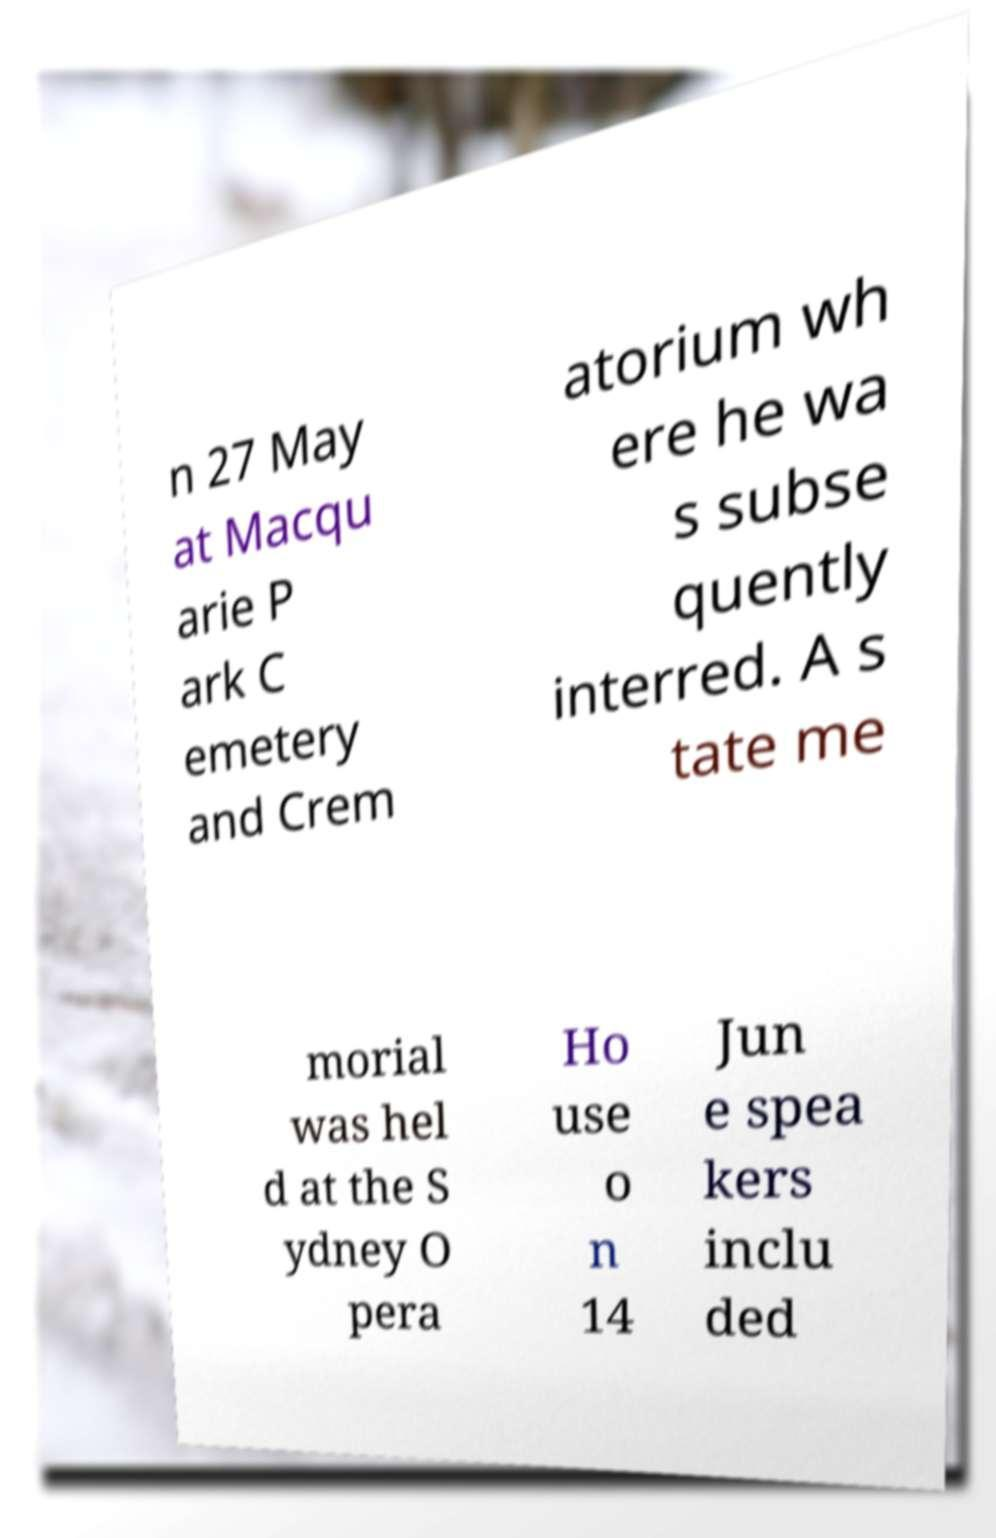Please read and relay the text visible in this image. What does it say? n 27 May at Macqu arie P ark C emetery and Crem atorium wh ere he wa s subse quently interred. A s tate me morial was hel d at the S ydney O pera Ho use o n 14 Jun e spea kers inclu ded 